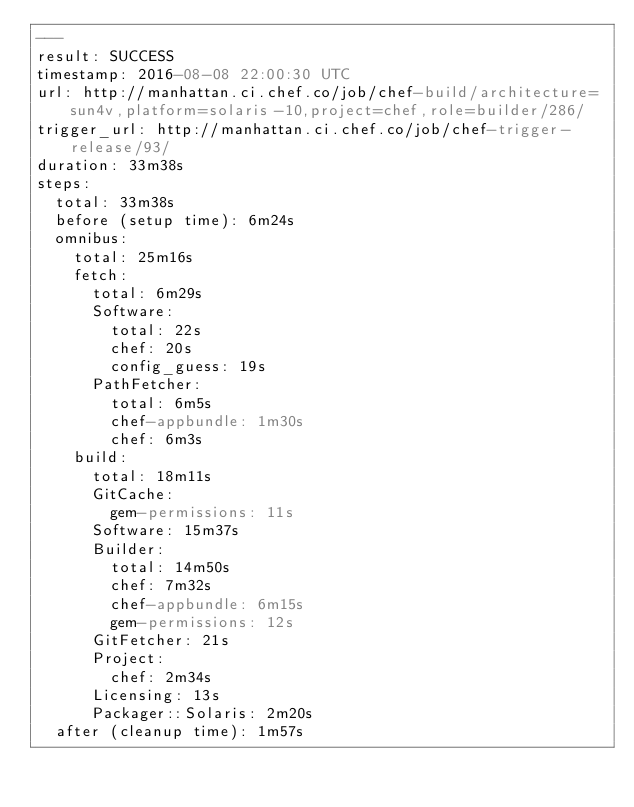<code> <loc_0><loc_0><loc_500><loc_500><_YAML_>---
result: SUCCESS
timestamp: 2016-08-08 22:00:30 UTC
url: http://manhattan.ci.chef.co/job/chef-build/architecture=sun4v,platform=solaris-10,project=chef,role=builder/286/
trigger_url: http://manhattan.ci.chef.co/job/chef-trigger-release/93/
duration: 33m38s
steps:
  total: 33m38s
  before (setup time): 6m24s
  omnibus:
    total: 25m16s
    fetch:
      total: 6m29s
      Software:
        total: 22s
        chef: 20s
        config_guess: 19s
      PathFetcher:
        total: 6m5s
        chef-appbundle: 1m30s
        chef: 6m3s
    build:
      total: 18m11s
      GitCache:
        gem-permissions: 11s
      Software: 15m37s
      Builder:
        total: 14m50s
        chef: 7m32s
        chef-appbundle: 6m15s
        gem-permissions: 12s
      GitFetcher: 21s
      Project:
        chef: 2m34s
      Licensing: 13s
      Packager::Solaris: 2m20s
  after (cleanup time): 1m57s
</code> 